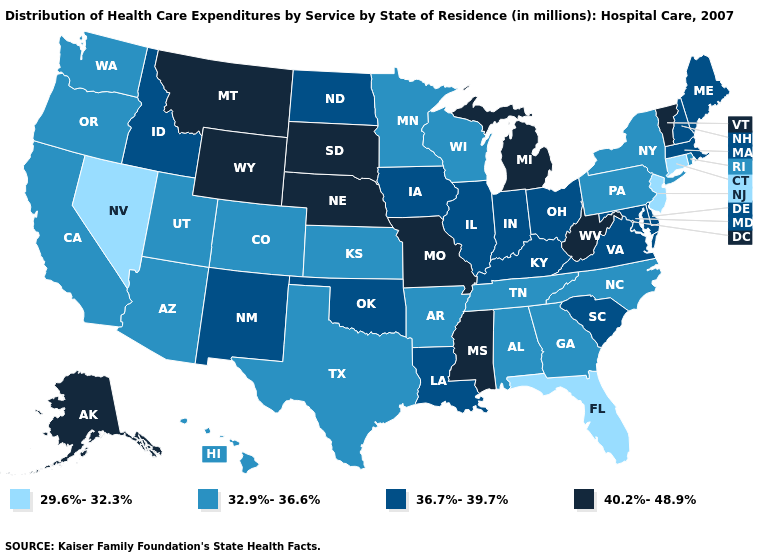Among the states that border Michigan , does Ohio have the lowest value?
Give a very brief answer. No. What is the value of California?
Concise answer only. 32.9%-36.6%. What is the highest value in states that border Oregon?
Write a very short answer. 36.7%-39.7%. What is the value of Missouri?
Quick response, please. 40.2%-48.9%. Does Florida have the lowest value in the South?
Answer briefly. Yes. How many symbols are there in the legend?
Concise answer only. 4. Name the states that have a value in the range 29.6%-32.3%?
Concise answer only. Connecticut, Florida, Nevada, New Jersey. Name the states that have a value in the range 29.6%-32.3%?
Give a very brief answer. Connecticut, Florida, Nevada, New Jersey. Among the states that border New Jersey , which have the highest value?
Concise answer only. Delaware. Does Idaho have a higher value than Colorado?
Answer briefly. Yes. What is the value of Tennessee?
Keep it brief. 32.9%-36.6%. How many symbols are there in the legend?
Give a very brief answer. 4. What is the value of Oklahoma?
Short answer required. 36.7%-39.7%. Does the map have missing data?
Be succinct. No. What is the value of Rhode Island?
Concise answer only. 32.9%-36.6%. 